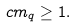Convert formula to latex. <formula><loc_0><loc_0><loc_500><loc_500>c m _ { q } \geq 1 .</formula> 